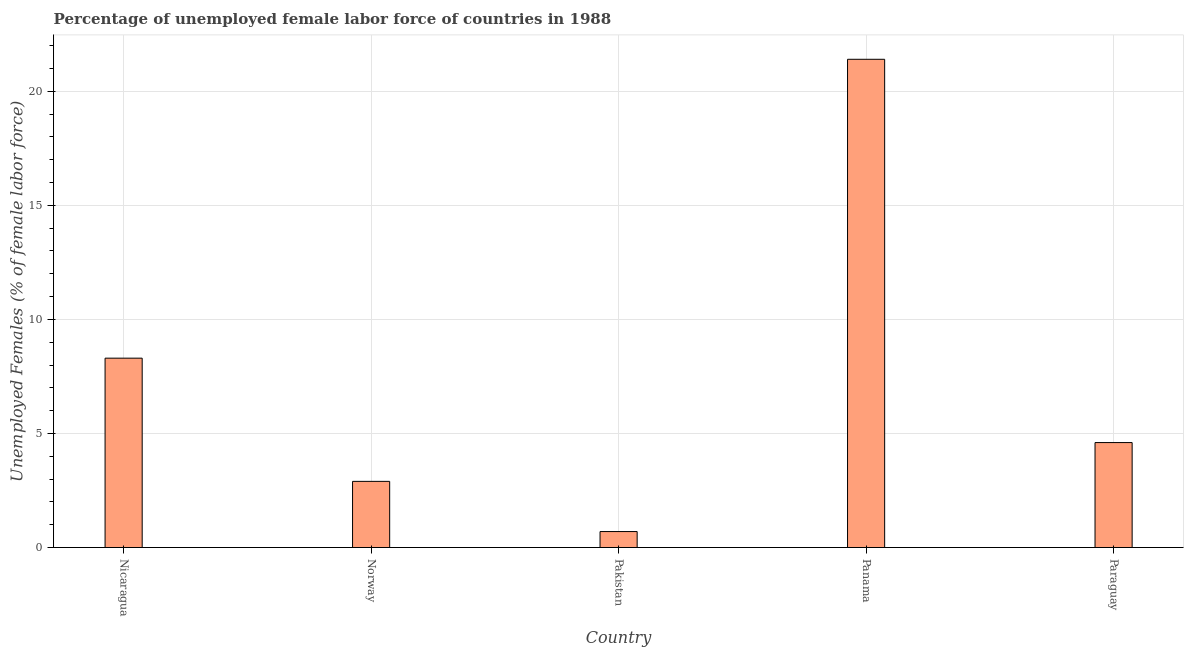Does the graph contain any zero values?
Make the answer very short. No. Does the graph contain grids?
Your answer should be compact. Yes. What is the title of the graph?
Your response must be concise. Percentage of unemployed female labor force of countries in 1988. What is the label or title of the X-axis?
Provide a succinct answer. Country. What is the label or title of the Y-axis?
Keep it short and to the point. Unemployed Females (% of female labor force). What is the total unemployed female labour force in Norway?
Your response must be concise. 2.9. Across all countries, what is the maximum total unemployed female labour force?
Keep it short and to the point. 21.4. Across all countries, what is the minimum total unemployed female labour force?
Offer a terse response. 0.7. In which country was the total unemployed female labour force maximum?
Make the answer very short. Panama. What is the sum of the total unemployed female labour force?
Give a very brief answer. 37.9. What is the average total unemployed female labour force per country?
Ensure brevity in your answer.  7.58. What is the median total unemployed female labour force?
Offer a terse response. 4.6. What is the ratio of the total unemployed female labour force in Nicaragua to that in Pakistan?
Ensure brevity in your answer.  11.86. Is the total unemployed female labour force in Norway less than that in Panama?
Your response must be concise. Yes. What is the difference between the highest and the second highest total unemployed female labour force?
Your response must be concise. 13.1. What is the difference between the highest and the lowest total unemployed female labour force?
Offer a very short reply. 20.7. In how many countries, is the total unemployed female labour force greater than the average total unemployed female labour force taken over all countries?
Your answer should be compact. 2. How many countries are there in the graph?
Ensure brevity in your answer.  5. What is the difference between two consecutive major ticks on the Y-axis?
Give a very brief answer. 5. Are the values on the major ticks of Y-axis written in scientific E-notation?
Make the answer very short. No. What is the Unemployed Females (% of female labor force) in Nicaragua?
Provide a succinct answer. 8.3. What is the Unemployed Females (% of female labor force) of Norway?
Provide a short and direct response. 2.9. What is the Unemployed Females (% of female labor force) in Pakistan?
Provide a short and direct response. 0.7. What is the Unemployed Females (% of female labor force) of Panama?
Ensure brevity in your answer.  21.4. What is the Unemployed Females (% of female labor force) of Paraguay?
Your answer should be very brief. 4.6. What is the difference between the Unemployed Females (% of female labor force) in Nicaragua and Norway?
Your answer should be very brief. 5.4. What is the difference between the Unemployed Females (% of female labor force) in Nicaragua and Pakistan?
Ensure brevity in your answer.  7.6. What is the difference between the Unemployed Females (% of female labor force) in Nicaragua and Panama?
Offer a very short reply. -13.1. What is the difference between the Unemployed Females (% of female labor force) in Norway and Pakistan?
Your answer should be very brief. 2.2. What is the difference between the Unemployed Females (% of female labor force) in Norway and Panama?
Offer a very short reply. -18.5. What is the difference between the Unemployed Females (% of female labor force) in Norway and Paraguay?
Your answer should be compact. -1.7. What is the difference between the Unemployed Females (% of female labor force) in Pakistan and Panama?
Ensure brevity in your answer.  -20.7. What is the difference between the Unemployed Females (% of female labor force) in Panama and Paraguay?
Offer a terse response. 16.8. What is the ratio of the Unemployed Females (% of female labor force) in Nicaragua to that in Norway?
Your answer should be compact. 2.86. What is the ratio of the Unemployed Females (% of female labor force) in Nicaragua to that in Pakistan?
Keep it short and to the point. 11.86. What is the ratio of the Unemployed Females (% of female labor force) in Nicaragua to that in Panama?
Your answer should be compact. 0.39. What is the ratio of the Unemployed Females (% of female labor force) in Nicaragua to that in Paraguay?
Provide a succinct answer. 1.8. What is the ratio of the Unemployed Females (% of female labor force) in Norway to that in Pakistan?
Your answer should be compact. 4.14. What is the ratio of the Unemployed Females (% of female labor force) in Norway to that in Panama?
Your answer should be compact. 0.14. What is the ratio of the Unemployed Females (% of female labor force) in Norway to that in Paraguay?
Provide a succinct answer. 0.63. What is the ratio of the Unemployed Females (% of female labor force) in Pakistan to that in Panama?
Make the answer very short. 0.03. What is the ratio of the Unemployed Females (% of female labor force) in Pakistan to that in Paraguay?
Ensure brevity in your answer.  0.15. What is the ratio of the Unemployed Females (% of female labor force) in Panama to that in Paraguay?
Your answer should be very brief. 4.65. 